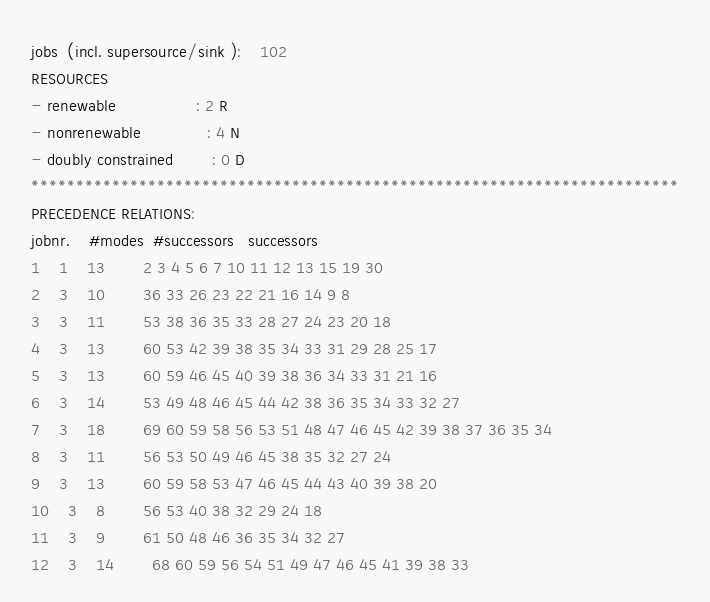<code> <loc_0><loc_0><loc_500><loc_500><_ObjectiveC_>jobs  (incl. supersource/sink ):	102
RESOURCES
- renewable                 : 2 R
- nonrenewable              : 4 N
- doubly constrained        : 0 D
************************************************************************
PRECEDENCE RELATIONS:
jobnr.    #modes  #successors   successors
1	1	13		2 3 4 5 6 7 10 11 12 13 15 19 30 
2	3	10		36 33 26 23 22 21 16 14 9 8 
3	3	11		53 38 36 35 33 28 27 24 23 20 18 
4	3	13		60 53 42 39 38 35 34 33 31 29 28 25 17 
5	3	13		60 59 46 45 40 39 38 36 34 33 31 21 16 
6	3	14		53 49 48 46 45 44 42 38 36 35 34 33 32 27 
7	3	18		69 60 59 58 56 53 51 48 47 46 45 42 39 38 37 36 35 34 
8	3	11		56 53 50 49 46 45 38 35 32 27 24 
9	3	13		60 59 58 53 47 46 45 44 43 40 39 38 20 
10	3	8		56 53 40 38 32 29 24 18 
11	3	9		61 50 48 46 36 35 34 32 27 
12	3	14		68 60 59 56 54 51 49 47 46 45 41 39 38 33 </code> 